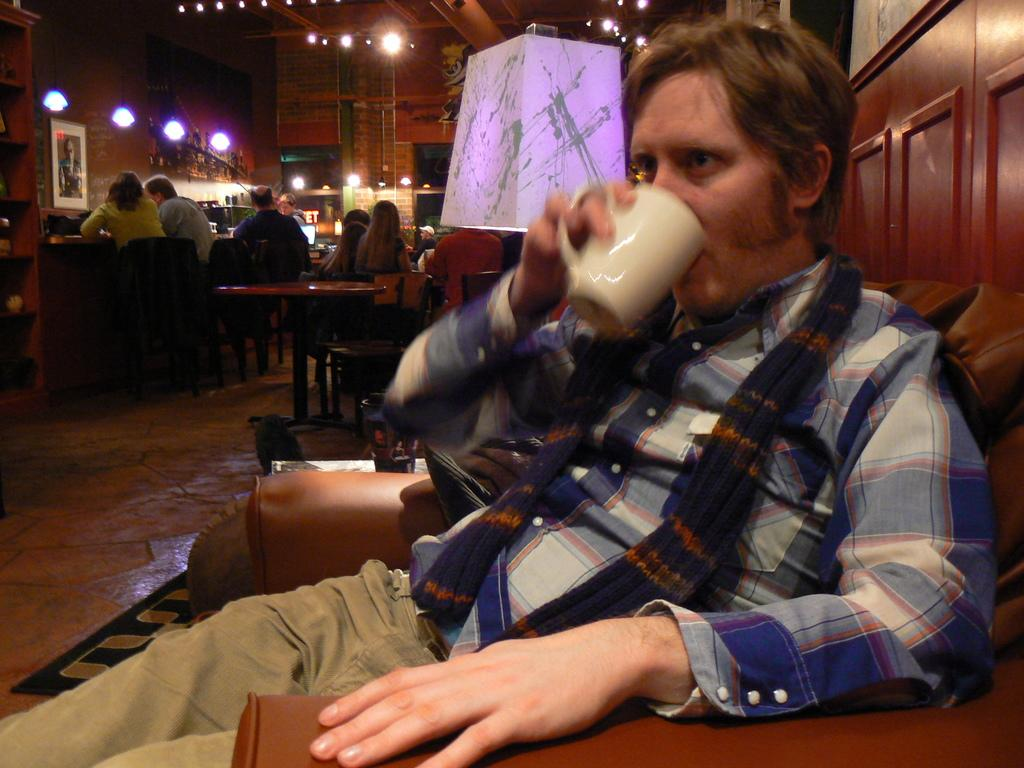Who is the main subject in the image? There is a boy in the image. Where is the boy located in the image? The boy is sitting on the right side of the image. What is the boy sitting on? The boy is sitting on a sofa. What can be seen in the background of the image? There are tables, chairs, and other people in the background of the image. What type of hose is the boy using to water the plants in the image? There is no hose present in the image, and the boy is not shown watering any plants. 